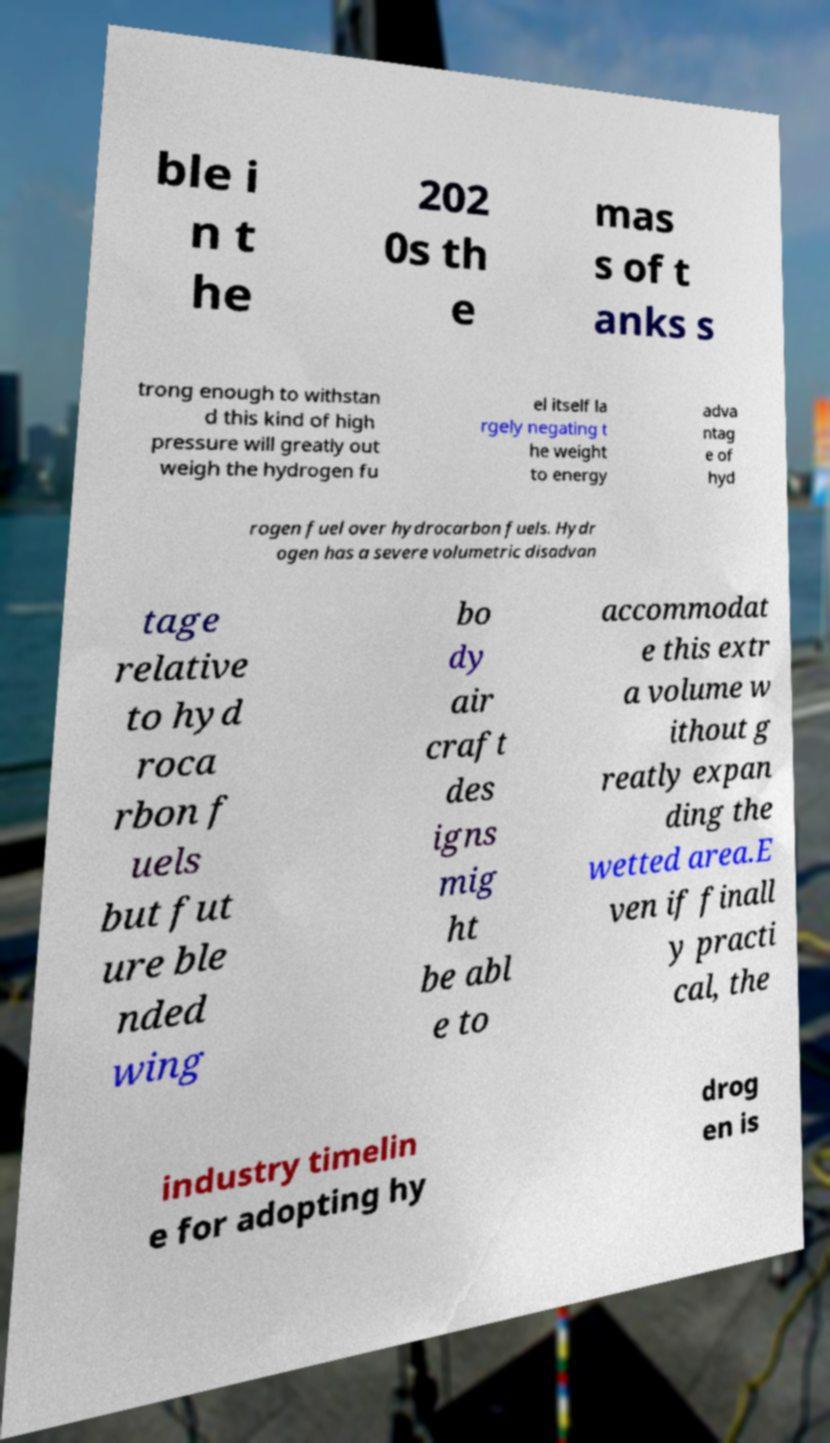Could you extract and type out the text from this image? ble i n t he 202 0s th e mas s of t anks s trong enough to withstan d this kind of high pressure will greatly out weigh the hydrogen fu el itself la rgely negating t he weight to energy adva ntag e of hyd rogen fuel over hydrocarbon fuels. Hydr ogen has a severe volumetric disadvan tage relative to hyd roca rbon f uels but fut ure ble nded wing bo dy air craft des igns mig ht be abl e to accommodat e this extr a volume w ithout g reatly expan ding the wetted area.E ven if finall y practi cal, the industry timelin e for adopting hy drog en is 